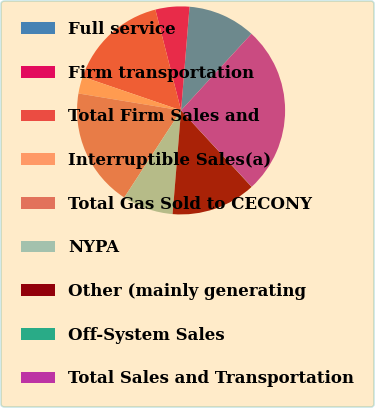Convert chart. <chart><loc_0><loc_0><loc_500><loc_500><pie_chart><fcel>Full service<fcel>Firm transportation<fcel>Total Firm Sales and<fcel>Interruptible Sales(a)<fcel>Total Gas Sold to CECONY<fcel>NYPA<fcel>Other (mainly generating<fcel>Off-System Sales<fcel>Total Sales and Transportation<nl><fcel>10.53%<fcel>5.27%<fcel>15.78%<fcel>2.64%<fcel>18.41%<fcel>7.9%<fcel>13.16%<fcel>0.02%<fcel>26.29%<nl></chart> 